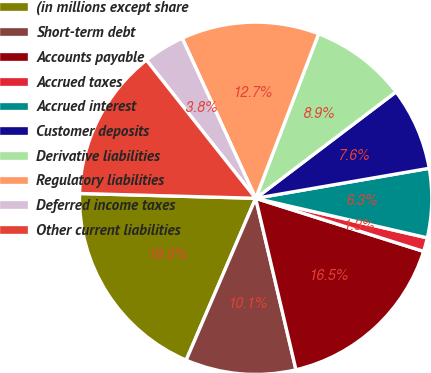Convert chart. <chart><loc_0><loc_0><loc_500><loc_500><pie_chart><fcel>(in millions except share<fcel>Short-term debt<fcel>Accounts payable<fcel>Accrued taxes<fcel>Accrued interest<fcel>Customer deposits<fcel>Derivative liabilities<fcel>Regulatory liabilities<fcel>Deferred income taxes<fcel>Other current liabilities<nl><fcel>18.98%<fcel>10.13%<fcel>16.45%<fcel>1.27%<fcel>6.33%<fcel>7.6%<fcel>8.86%<fcel>12.66%<fcel>3.8%<fcel>13.92%<nl></chart> 